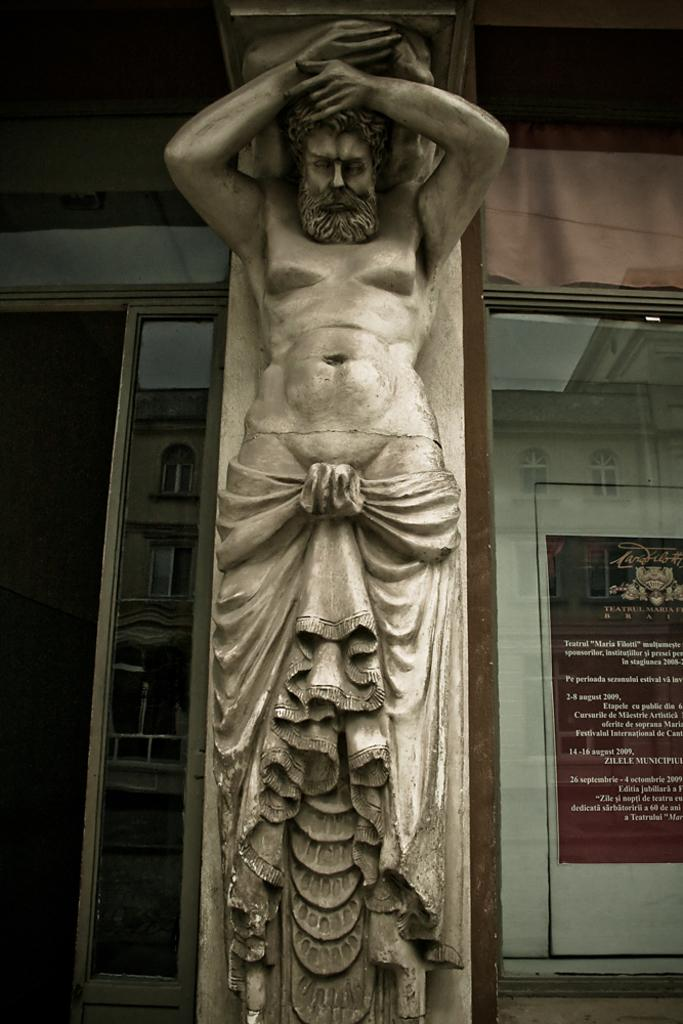What is the main subject in the center of the image? There is a sculpture in the center of the image. What can be seen on the left side of the image? There is a door on the left side of the image. What is visible in the background of the image? There is a wall in the background of the image. What is placed on the wall in the background? There is a board placed on the wall in the background. How many apples are hanging from the sculpture in the image? There are no apples present in the image; the sculpture is the main subject. 